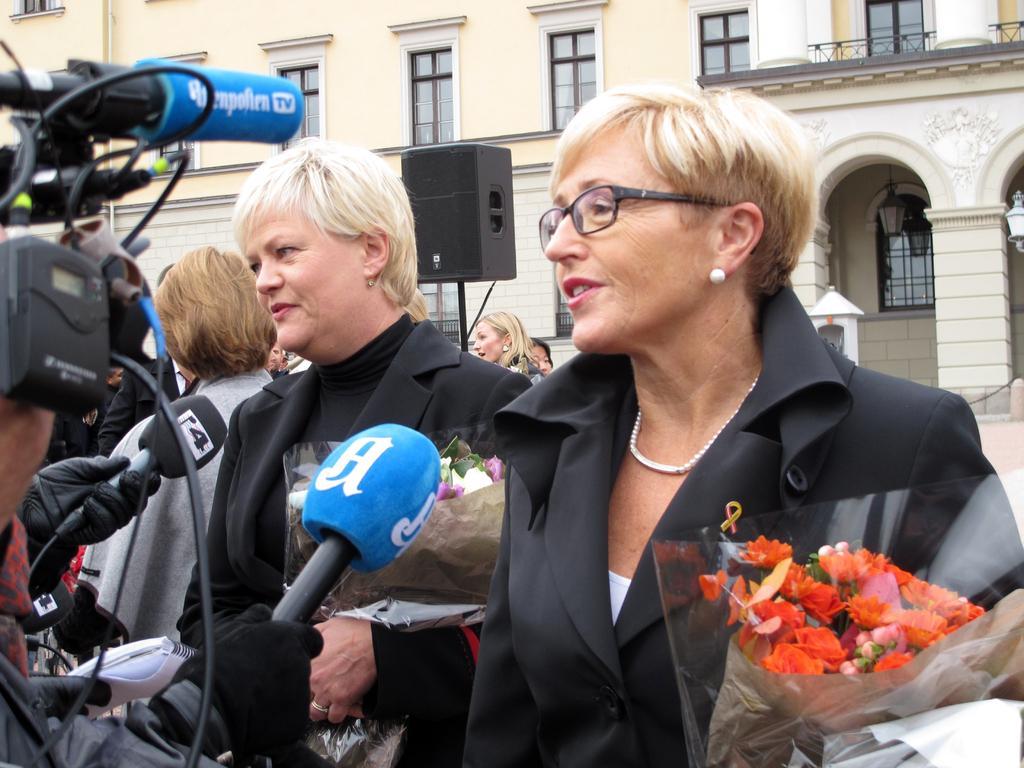Can you describe this image briefly? In this image there are two women standing and holding bouquets in their hands are addressing the media, behind them there are a few other women, a speaker and a building. 